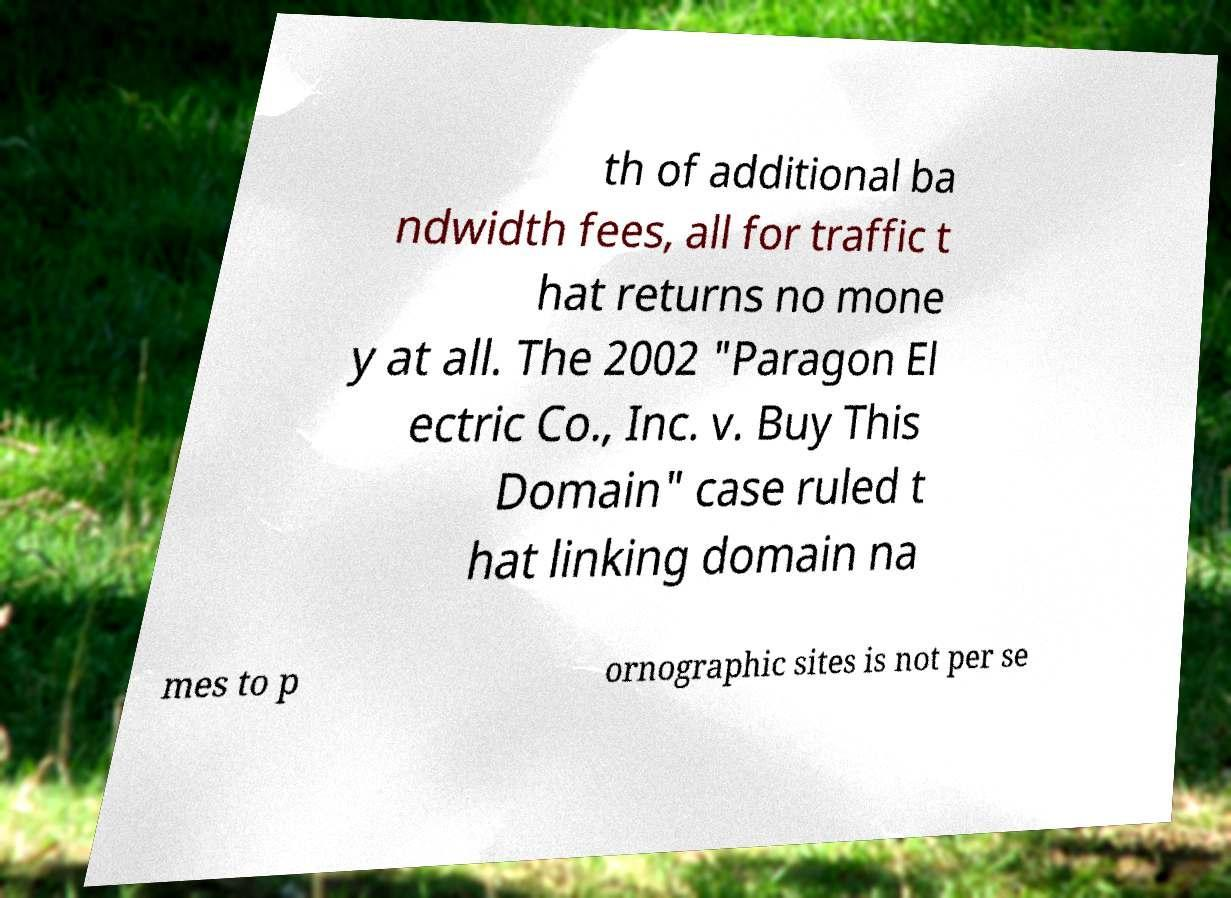Can you accurately transcribe the text from the provided image for me? th of additional ba ndwidth fees, all for traffic t hat returns no mone y at all. The 2002 "Paragon El ectric Co., Inc. v. Buy This Domain" case ruled t hat linking domain na mes to p ornographic sites is not per se 